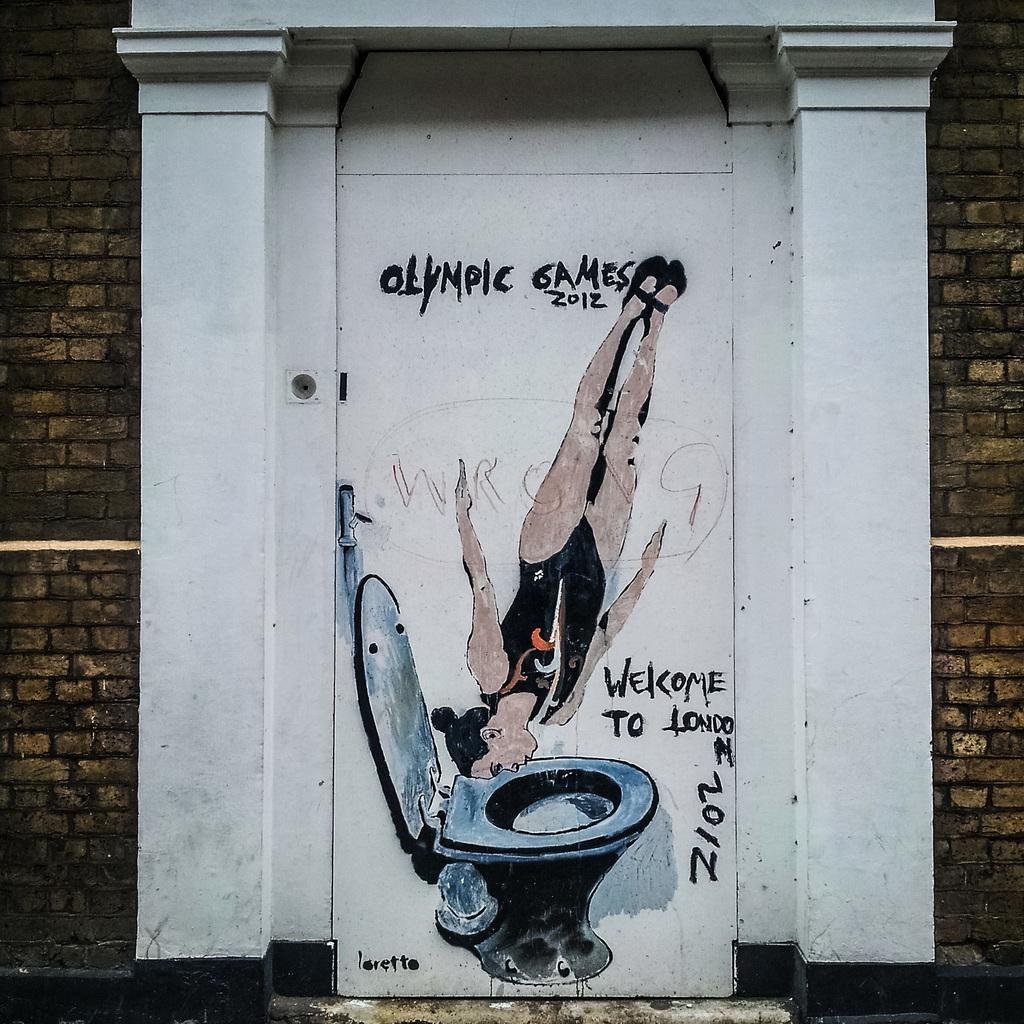<image>
Give a short and clear explanation of the subsequent image. A painting on a white door depicts a person diving into a toilet while advertising the Olympic Games 2012 and saying "Welcome to London". 